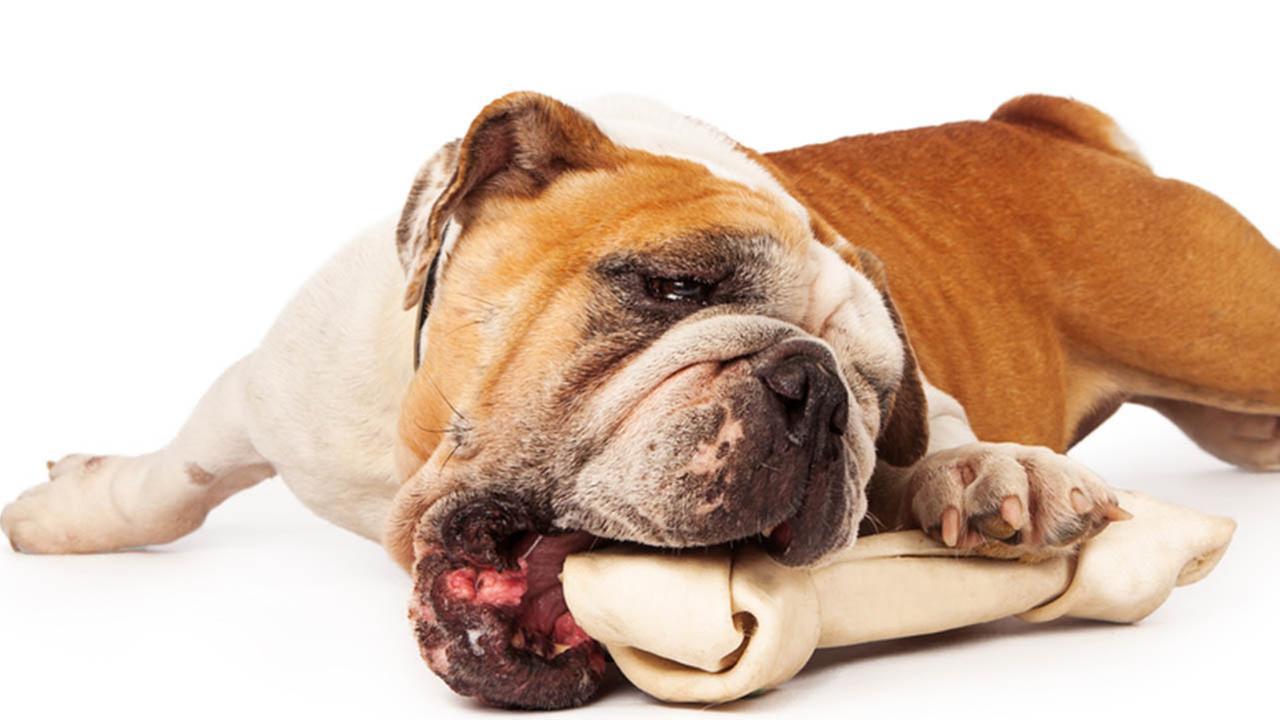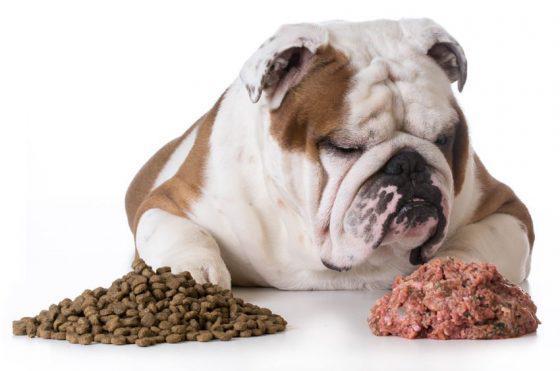The first image is the image on the left, the second image is the image on the right. Assess this claim about the two images: "One of the images features a dog chewing an object.". Correct or not? Answer yes or no. Yes. The first image is the image on the left, the second image is the image on the right. Considering the images on both sides, is "Each image features one bulldog posed with something in front of its face, and the dog on the left is gnawing on something." valid? Answer yes or no. Yes. 